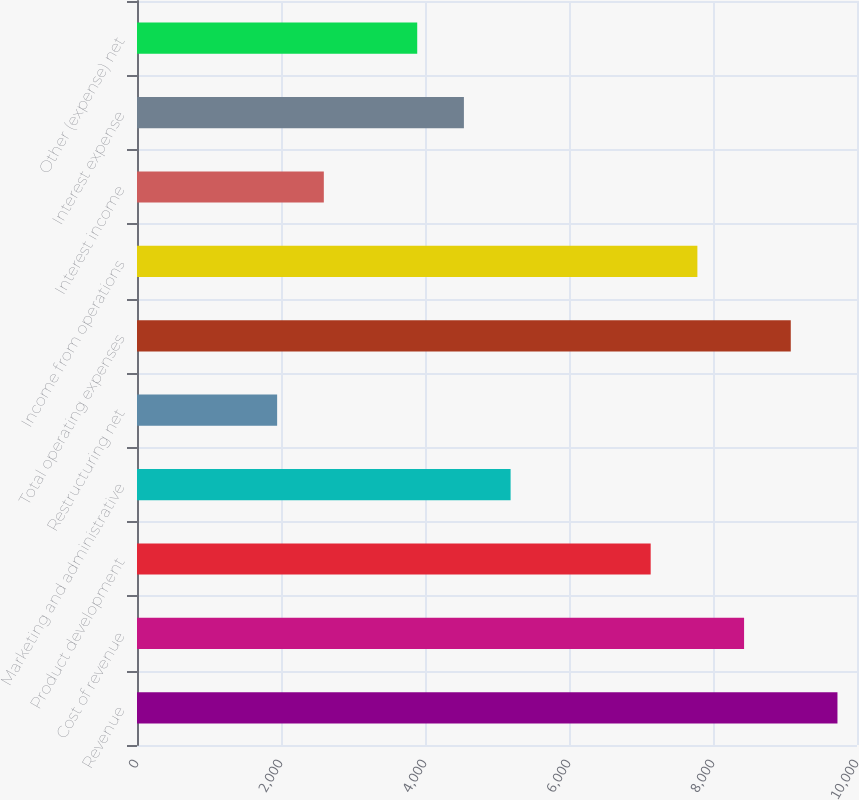<chart> <loc_0><loc_0><loc_500><loc_500><bar_chart><fcel>Revenue<fcel>Cost of revenue<fcel>Product development<fcel>Marketing and administrative<fcel>Restructuring net<fcel>Total operating expenses<fcel>Income from operations<fcel>Interest income<fcel>Interest expense<fcel>Other (expense) net<nl><fcel>9728.66<fcel>8431.6<fcel>7134.54<fcel>5188.95<fcel>1946.3<fcel>9080.13<fcel>7783.07<fcel>2594.83<fcel>4540.42<fcel>3891.89<nl></chart> 